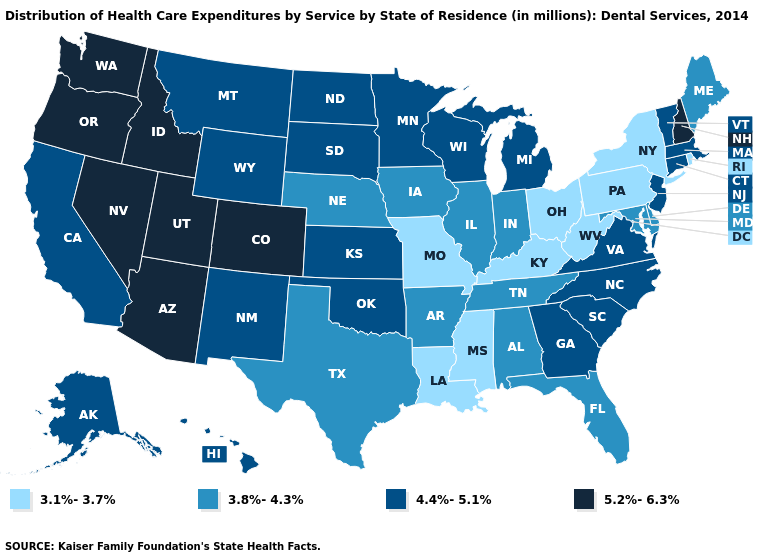What is the value of Connecticut?
Write a very short answer. 4.4%-5.1%. Name the states that have a value in the range 3.8%-4.3%?
Write a very short answer. Alabama, Arkansas, Delaware, Florida, Illinois, Indiana, Iowa, Maine, Maryland, Nebraska, Tennessee, Texas. Name the states that have a value in the range 5.2%-6.3%?
Be succinct. Arizona, Colorado, Idaho, Nevada, New Hampshire, Oregon, Utah, Washington. What is the lowest value in the West?
Give a very brief answer. 4.4%-5.1%. Name the states that have a value in the range 5.2%-6.3%?
Short answer required. Arizona, Colorado, Idaho, Nevada, New Hampshire, Oregon, Utah, Washington. What is the value of Nevada?
Give a very brief answer. 5.2%-6.3%. Does the map have missing data?
Answer briefly. No. Among the states that border Louisiana , does Mississippi have the lowest value?
Write a very short answer. Yes. Does Louisiana have the lowest value in the USA?
Short answer required. Yes. Among the states that border Wyoming , which have the lowest value?
Answer briefly. Nebraska. Among the states that border Delaware , does Pennsylvania have the lowest value?
Give a very brief answer. Yes. Does Florida have the same value as New York?
Short answer required. No. Does Alaska have the same value as Oregon?
Quick response, please. No. Which states have the lowest value in the MidWest?
Short answer required. Missouri, Ohio. Which states have the lowest value in the USA?
Give a very brief answer. Kentucky, Louisiana, Mississippi, Missouri, New York, Ohio, Pennsylvania, Rhode Island, West Virginia. 